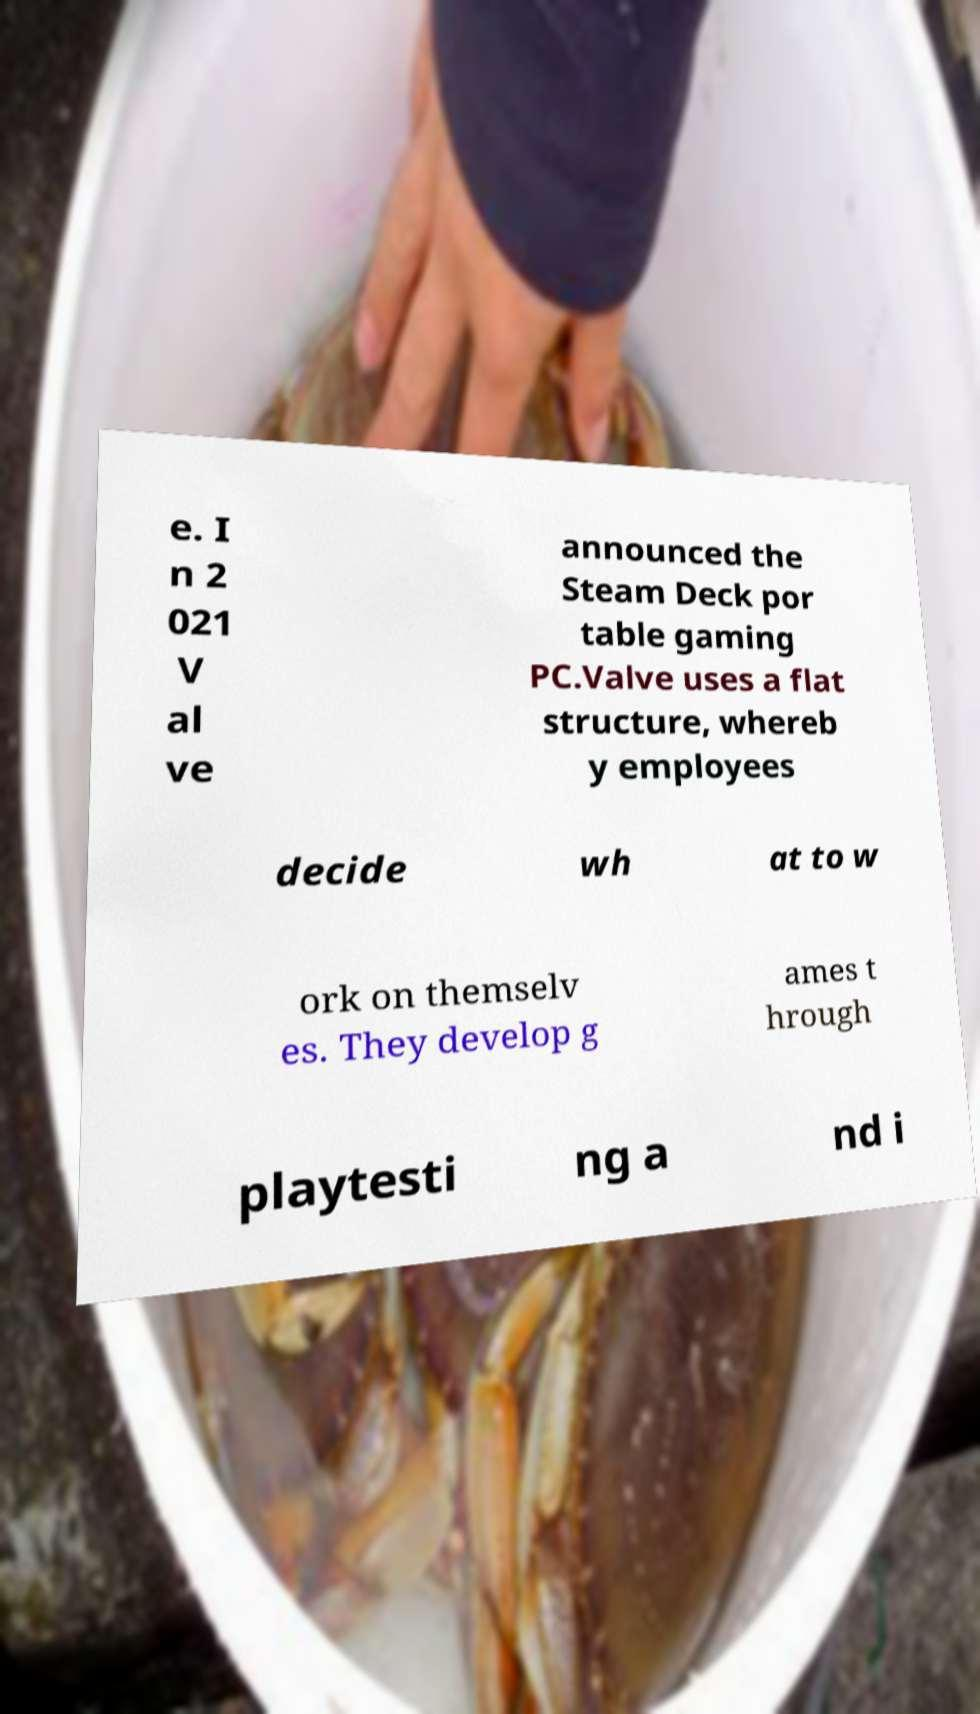What messages or text are displayed in this image? I need them in a readable, typed format. e. I n 2 021 V al ve announced the Steam Deck por table gaming PC.Valve uses a flat structure, whereb y employees decide wh at to w ork on themselv es. They develop g ames t hrough playtesti ng a nd i 